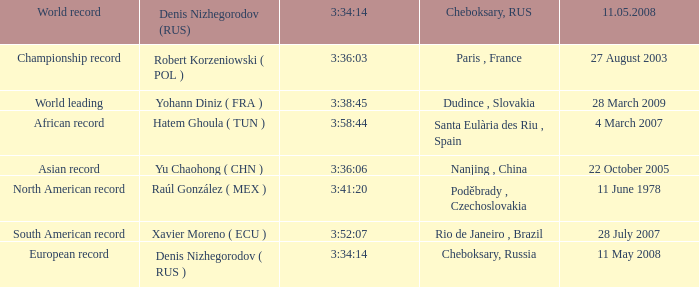When north american record is the world record who is the denis nizhegorodov ( rus )? Raúl González ( MEX ). 